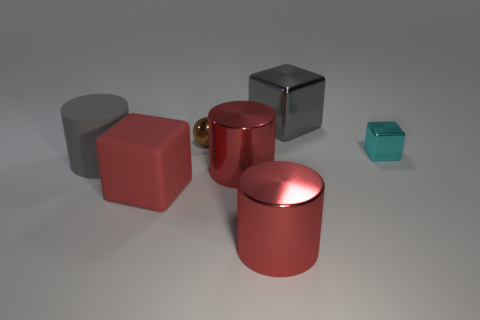Does the cube on the right side of the gray metallic cube have the same material as the big cylinder in front of the red cube?
Offer a very short reply. Yes. What number of brown balls are right of the brown metallic ball?
Your answer should be compact. 0. What number of purple things are either large cubes or cubes?
Make the answer very short. 0. What is the material of the gray object that is the same size as the gray cube?
Offer a very short reply. Rubber. There is a large metallic thing that is both in front of the brown ball and behind the big red matte cube; what shape is it?
Offer a terse response. Cylinder. The sphere that is the same size as the cyan cube is what color?
Ensure brevity in your answer.  Brown. Is the size of the gray thing in front of the tiny cyan metallic cube the same as the rubber object on the right side of the gray rubber object?
Make the answer very short. Yes. There is a cube to the left of the large metallic cube behind the thing that is in front of the big red rubber cube; how big is it?
Ensure brevity in your answer.  Large. What shape is the big red object that is in front of the big block in front of the brown metallic sphere?
Offer a terse response. Cylinder. There is a big matte thing that is behind the matte cube; does it have the same color as the small block?
Ensure brevity in your answer.  No. 